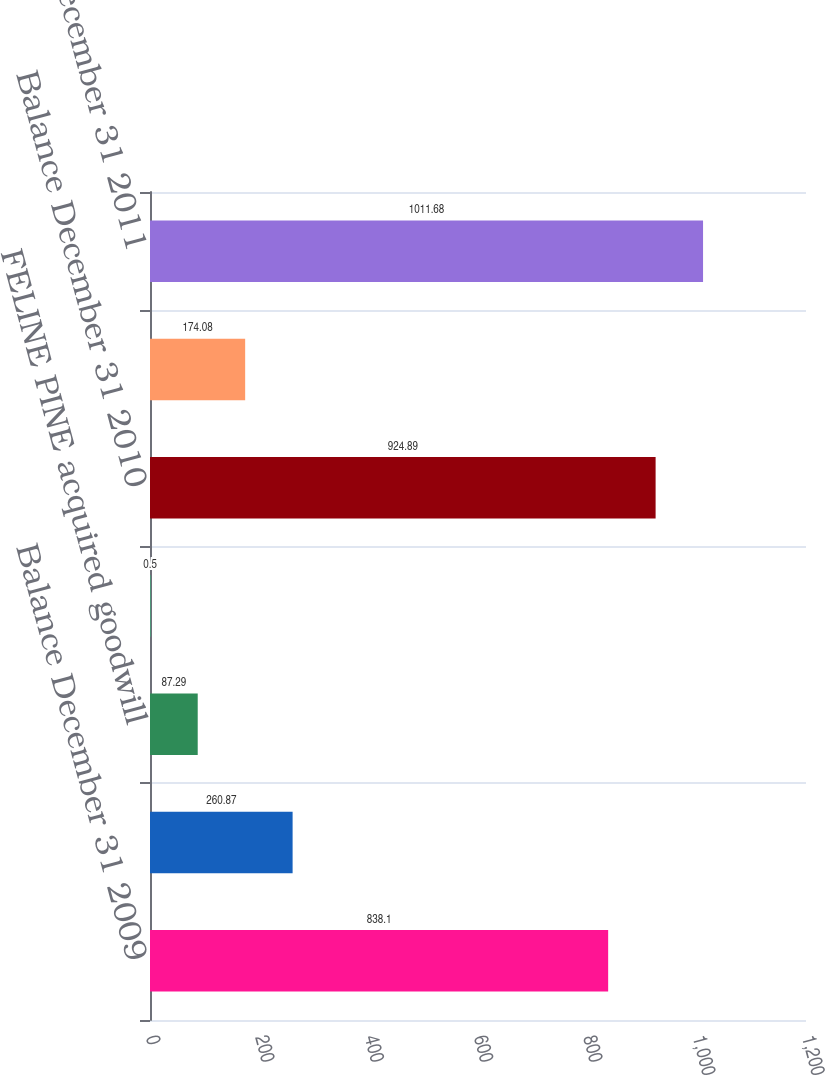Convert chart. <chart><loc_0><loc_0><loc_500><loc_500><bar_chart><fcel>Balance December 31 2009<fcel>SIMPLY SALINE acquired<fcel>FELINE PINE acquired goodwill<fcel>Additional contingent<fcel>Balance December 31 2010<fcel>BATISTE acquired goodwill<fcel>Balance December 31 2011<nl><fcel>838.1<fcel>260.87<fcel>87.29<fcel>0.5<fcel>924.89<fcel>174.08<fcel>1011.68<nl></chart> 